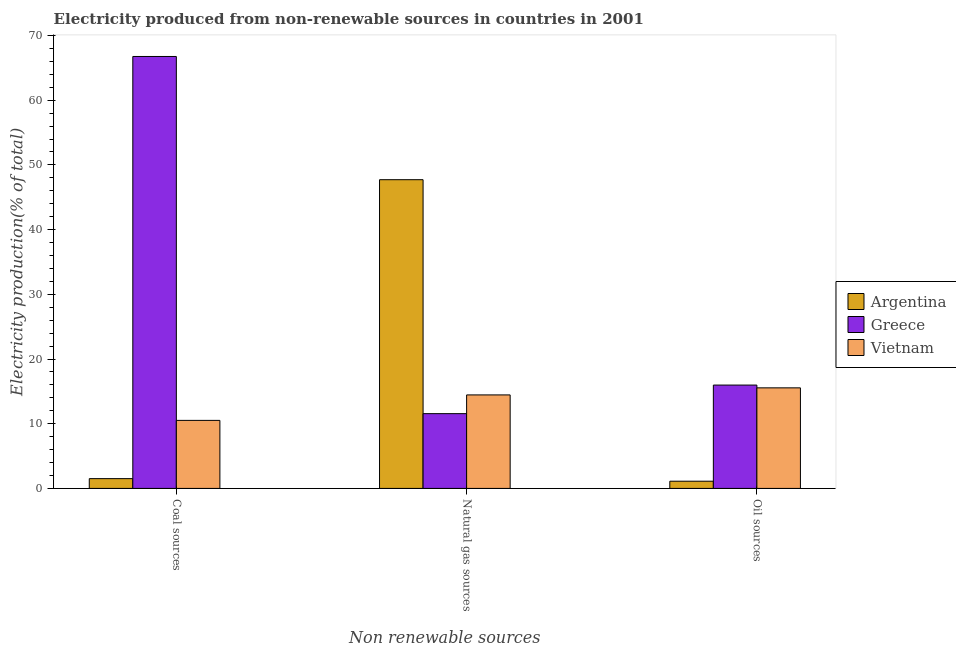How many different coloured bars are there?
Give a very brief answer. 3. How many groups of bars are there?
Provide a succinct answer. 3. How many bars are there on the 2nd tick from the left?
Keep it short and to the point. 3. What is the label of the 3rd group of bars from the left?
Provide a short and direct response. Oil sources. What is the percentage of electricity produced by oil sources in Vietnam?
Make the answer very short. 15.54. Across all countries, what is the maximum percentage of electricity produced by natural gas?
Make the answer very short. 47.71. Across all countries, what is the minimum percentage of electricity produced by oil sources?
Provide a succinct answer. 1.11. In which country was the percentage of electricity produced by oil sources maximum?
Make the answer very short. Greece. What is the total percentage of electricity produced by oil sources in the graph?
Provide a succinct answer. 32.63. What is the difference between the percentage of electricity produced by oil sources in Argentina and that in Greece?
Your answer should be compact. -14.86. What is the difference between the percentage of electricity produced by natural gas in Greece and the percentage of electricity produced by oil sources in Argentina?
Your answer should be very brief. 10.44. What is the average percentage of electricity produced by coal per country?
Ensure brevity in your answer.  26.26. What is the difference between the percentage of electricity produced by oil sources and percentage of electricity produced by coal in Argentina?
Provide a short and direct response. -0.4. In how many countries, is the percentage of electricity produced by coal greater than 58 %?
Give a very brief answer. 1. What is the ratio of the percentage of electricity produced by oil sources in Greece to that in Vietnam?
Offer a very short reply. 1.03. Is the percentage of electricity produced by natural gas in Vietnam less than that in Greece?
Provide a succinct answer. No. Is the difference between the percentage of electricity produced by coal in Vietnam and Greece greater than the difference between the percentage of electricity produced by oil sources in Vietnam and Greece?
Provide a short and direct response. No. What is the difference between the highest and the second highest percentage of electricity produced by oil sources?
Offer a very short reply. 0.43. What is the difference between the highest and the lowest percentage of electricity produced by natural gas?
Make the answer very short. 36.16. In how many countries, is the percentage of electricity produced by coal greater than the average percentage of electricity produced by coal taken over all countries?
Make the answer very short. 1. What does the 1st bar from the right in Natural gas sources represents?
Your answer should be very brief. Vietnam. Are all the bars in the graph horizontal?
Provide a short and direct response. No. Are the values on the major ticks of Y-axis written in scientific E-notation?
Your answer should be compact. No. Does the graph contain grids?
Provide a succinct answer. No. Where does the legend appear in the graph?
Provide a succinct answer. Center right. What is the title of the graph?
Your answer should be compact. Electricity produced from non-renewable sources in countries in 2001. What is the label or title of the X-axis?
Ensure brevity in your answer.  Non renewable sources. What is the Electricity production(% of total) in Argentina in Coal sources?
Keep it short and to the point. 1.51. What is the Electricity production(% of total) of Greece in Coal sources?
Give a very brief answer. 66.76. What is the Electricity production(% of total) in Vietnam in Coal sources?
Offer a very short reply. 10.51. What is the Electricity production(% of total) of Argentina in Natural gas sources?
Offer a terse response. 47.71. What is the Electricity production(% of total) of Greece in Natural gas sources?
Provide a succinct answer. 11.56. What is the Electricity production(% of total) of Vietnam in Natural gas sources?
Your response must be concise. 14.45. What is the Electricity production(% of total) of Argentina in Oil sources?
Make the answer very short. 1.11. What is the Electricity production(% of total) of Greece in Oil sources?
Your answer should be very brief. 15.97. What is the Electricity production(% of total) of Vietnam in Oil sources?
Offer a very short reply. 15.54. Across all Non renewable sources, what is the maximum Electricity production(% of total) of Argentina?
Provide a succinct answer. 47.71. Across all Non renewable sources, what is the maximum Electricity production(% of total) in Greece?
Make the answer very short. 66.76. Across all Non renewable sources, what is the maximum Electricity production(% of total) of Vietnam?
Give a very brief answer. 15.54. Across all Non renewable sources, what is the minimum Electricity production(% of total) of Argentina?
Make the answer very short. 1.11. Across all Non renewable sources, what is the minimum Electricity production(% of total) in Greece?
Your answer should be very brief. 11.56. Across all Non renewable sources, what is the minimum Electricity production(% of total) of Vietnam?
Give a very brief answer. 10.51. What is the total Electricity production(% of total) in Argentina in the graph?
Provide a short and direct response. 50.34. What is the total Electricity production(% of total) in Greece in the graph?
Ensure brevity in your answer.  94.28. What is the total Electricity production(% of total) in Vietnam in the graph?
Provide a succinct answer. 40.51. What is the difference between the Electricity production(% of total) of Argentina in Coal sources and that in Natural gas sources?
Provide a succinct answer. -46.2. What is the difference between the Electricity production(% of total) of Greece in Coal sources and that in Natural gas sources?
Offer a terse response. 55.2. What is the difference between the Electricity production(% of total) of Vietnam in Coal sources and that in Natural gas sources?
Your response must be concise. -3.94. What is the difference between the Electricity production(% of total) of Argentina in Coal sources and that in Oil sources?
Your answer should be compact. 0.4. What is the difference between the Electricity production(% of total) in Greece in Coal sources and that in Oil sources?
Give a very brief answer. 50.78. What is the difference between the Electricity production(% of total) in Vietnam in Coal sources and that in Oil sources?
Make the answer very short. -5.03. What is the difference between the Electricity production(% of total) of Argentina in Natural gas sources and that in Oil sources?
Your response must be concise. 46.6. What is the difference between the Electricity production(% of total) in Greece in Natural gas sources and that in Oil sources?
Offer a very short reply. -4.42. What is the difference between the Electricity production(% of total) in Vietnam in Natural gas sources and that in Oil sources?
Provide a succinct answer. -1.09. What is the difference between the Electricity production(% of total) of Argentina in Coal sources and the Electricity production(% of total) of Greece in Natural gas sources?
Your answer should be very brief. -10.04. What is the difference between the Electricity production(% of total) in Argentina in Coal sources and the Electricity production(% of total) in Vietnam in Natural gas sources?
Provide a short and direct response. -12.94. What is the difference between the Electricity production(% of total) of Greece in Coal sources and the Electricity production(% of total) of Vietnam in Natural gas sources?
Offer a very short reply. 52.3. What is the difference between the Electricity production(% of total) in Argentina in Coal sources and the Electricity production(% of total) in Greece in Oil sources?
Make the answer very short. -14.46. What is the difference between the Electricity production(% of total) of Argentina in Coal sources and the Electricity production(% of total) of Vietnam in Oil sources?
Provide a short and direct response. -14.03. What is the difference between the Electricity production(% of total) of Greece in Coal sources and the Electricity production(% of total) of Vietnam in Oil sources?
Give a very brief answer. 51.21. What is the difference between the Electricity production(% of total) of Argentina in Natural gas sources and the Electricity production(% of total) of Greece in Oil sources?
Your answer should be compact. 31.74. What is the difference between the Electricity production(% of total) of Argentina in Natural gas sources and the Electricity production(% of total) of Vietnam in Oil sources?
Your answer should be very brief. 32.17. What is the difference between the Electricity production(% of total) in Greece in Natural gas sources and the Electricity production(% of total) in Vietnam in Oil sources?
Your response must be concise. -3.99. What is the average Electricity production(% of total) of Argentina per Non renewable sources?
Your answer should be compact. 16.78. What is the average Electricity production(% of total) of Greece per Non renewable sources?
Give a very brief answer. 31.43. What is the average Electricity production(% of total) in Vietnam per Non renewable sources?
Ensure brevity in your answer.  13.5. What is the difference between the Electricity production(% of total) in Argentina and Electricity production(% of total) in Greece in Coal sources?
Your answer should be very brief. -65.24. What is the difference between the Electricity production(% of total) of Argentina and Electricity production(% of total) of Vietnam in Coal sources?
Offer a terse response. -9. What is the difference between the Electricity production(% of total) of Greece and Electricity production(% of total) of Vietnam in Coal sources?
Keep it short and to the point. 56.24. What is the difference between the Electricity production(% of total) of Argentina and Electricity production(% of total) of Greece in Natural gas sources?
Keep it short and to the point. 36.16. What is the difference between the Electricity production(% of total) in Argentina and Electricity production(% of total) in Vietnam in Natural gas sources?
Keep it short and to the point. 33.26. What is the difference between the Electricity production(% of total) in Greece and Electricity production(% of total) in Vietnam in Natural gas sources?
Your response must be concise. -2.9. What is the difference between the Electricity production(% of total) in Argentina and Electricity production(% of total) in Greece in Oil sources?
Give a very brief answer. -14.86. What is the difference between the Electricity production(% of total) of Argentina and Electricity production(% of total) of Vietnam in Oil sources?
Your answer should be compact. -14.43. What is the difference between the Electricity production(% of total) of Greece and Electricity production(% of total) of Vietnam in Oil sources?
Provide a short and direct response. 0.43. What is the ratio of the Electricity production(% of total) of Argentina in Coal sources to that in Natural gas sources?
Your answer should be compact. 0.03. What is the ratio of the Electricity production(% of total) of Greece in Coal sources to that in Natural gas sources?
Give a very brief answer. 5.78. What is the ratio of the Electricity production(% of total) of Vietnam in Coal sources to that in Natural gas sources?
Provide a short and direct response. 0.73. What is the ratio of the Electricity production(% of total) of Argentina in Coal sources to that in Oil sources?
Give a very brief answer. 1.36. What is the ratio of the Electricity production(% of total) in Greece in Coal sources to that in Oil sources?
Your response must be concise. 4.18. What is the ratio of the Electricity production(% of total) of Vietnam in Coal sources to that in Oil sources?
Your answer should be very brief. 0.68. What is the ratio of the Electricity production(% of total) in Argentina in Natural gas sources to that in Oil sources?
Make the answer very short. 42.82. What is the ratio of the Electricity production(% of total) of Greece in Natural gas sources to that in Oil sources?
Offer a terse response. 0.72. What is the ratio of the Electricity production(% of total) in Vietnam in Natural gas sources to that in Oil sources?
Offer a very short reply. 0.93. What is the difference between the highest and the second highest Electricity production(% of total) of Argentina?
Offer a terse response. 46.2. What is the difference between the highest and the second highest Electricity production(% of total) in Greece?
Provide a succinct answer. 50.78. What is the difference between the highest and the second highest Electricity production(% of total) in Vietnam?
Your answer should be compact. 1.09. What is the difference between the highest and the lowest Electricity production(% of total) of Argentina?
Give a very brief answer. 46.6. What is the difference between the highest and the lowest Electricity production(% of total) of Greece?
Offer a terse response. 55.2. What is the difference between the highest and the lowest Electricity production(% of total) in Vietnam?
Your answer should be very brief. 5.03. 